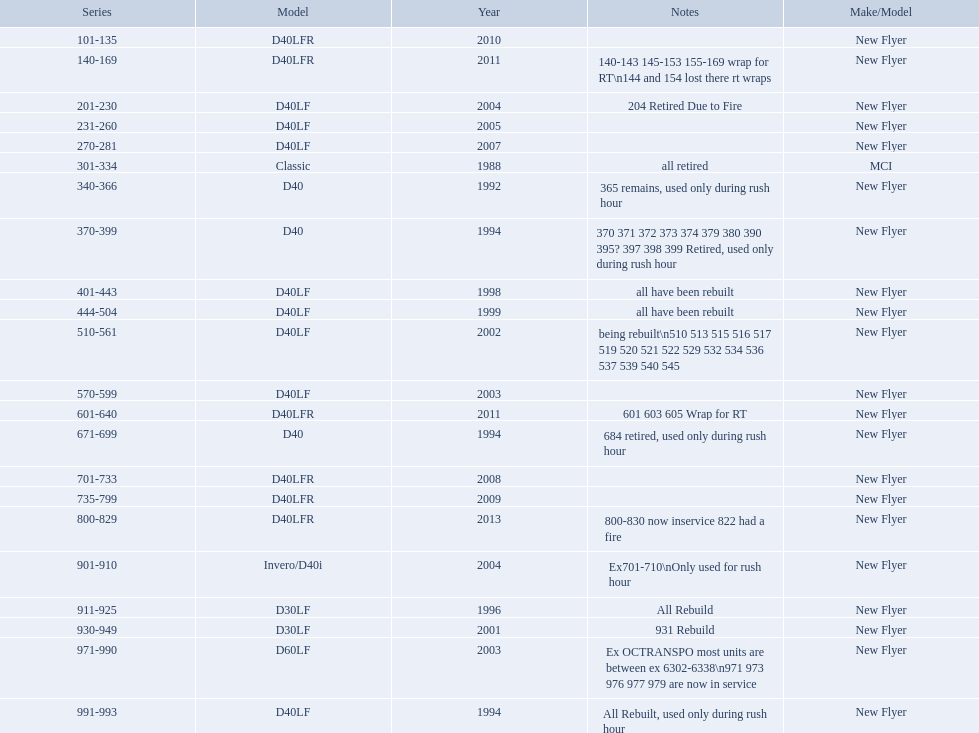What are all the series of buses? 101-135, 140-169, 201-230, 231-260, 270-281, 301-334, 340-366, 370-399, 401-443, 444-504, 510-561, 570-599, 601-640, 671-699, 701-733, 735-799, 800-829, 901-910, 911-925, 930-949, 971-990, 991-993. Which are the newest? 800-829. 